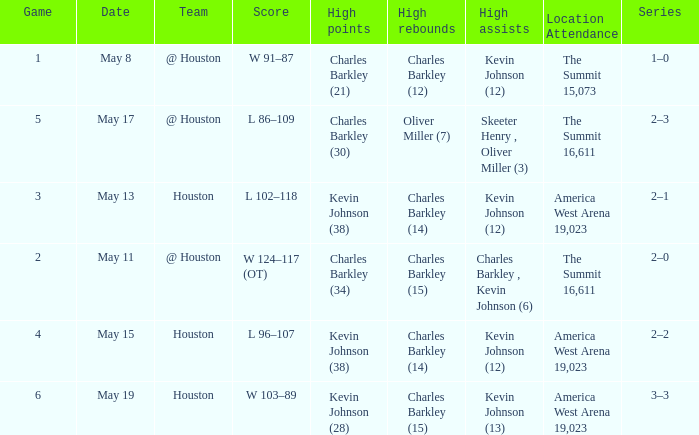In how many different games did Oliver Miller (7) did the high rebounds? 1.0. 